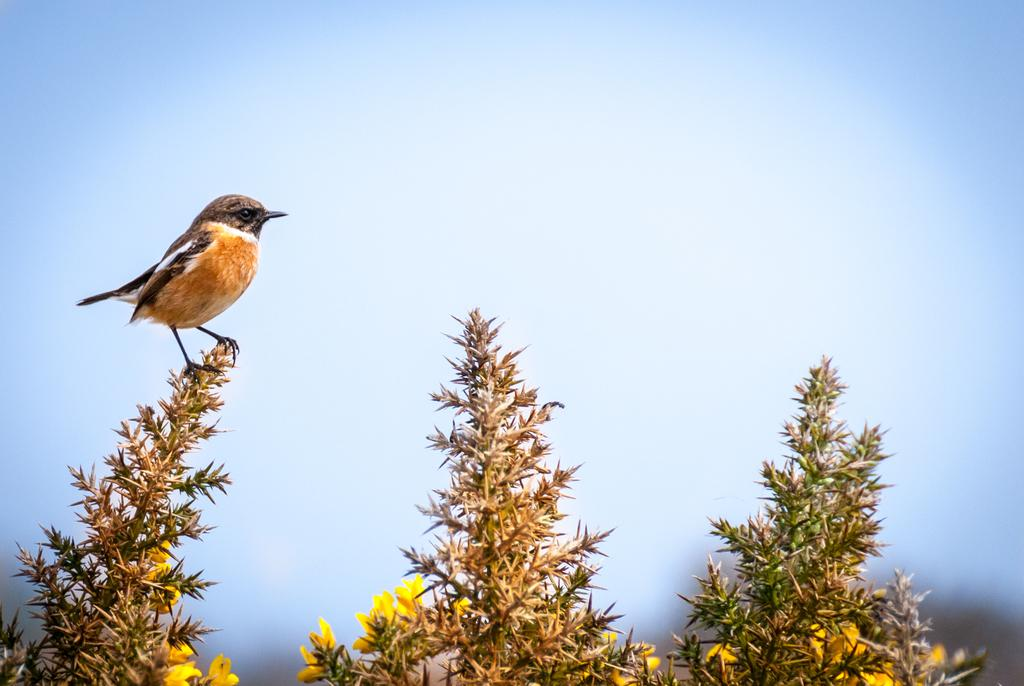What type of animal can be seen in the image? There is a bird in the image. What other living organisms are present in the image? There are plants and flowers in the image. What can be seen in the background of the image? The sky is visible in the background of the image. What type of cake is being used as an apparatus in the image? There is no cake or apparatus present in the image. Can you describe the brush that is being used to paint the flowers in the image? There is no brush or painting activity depicted in the image; it features a bird, plants, and flowers. 